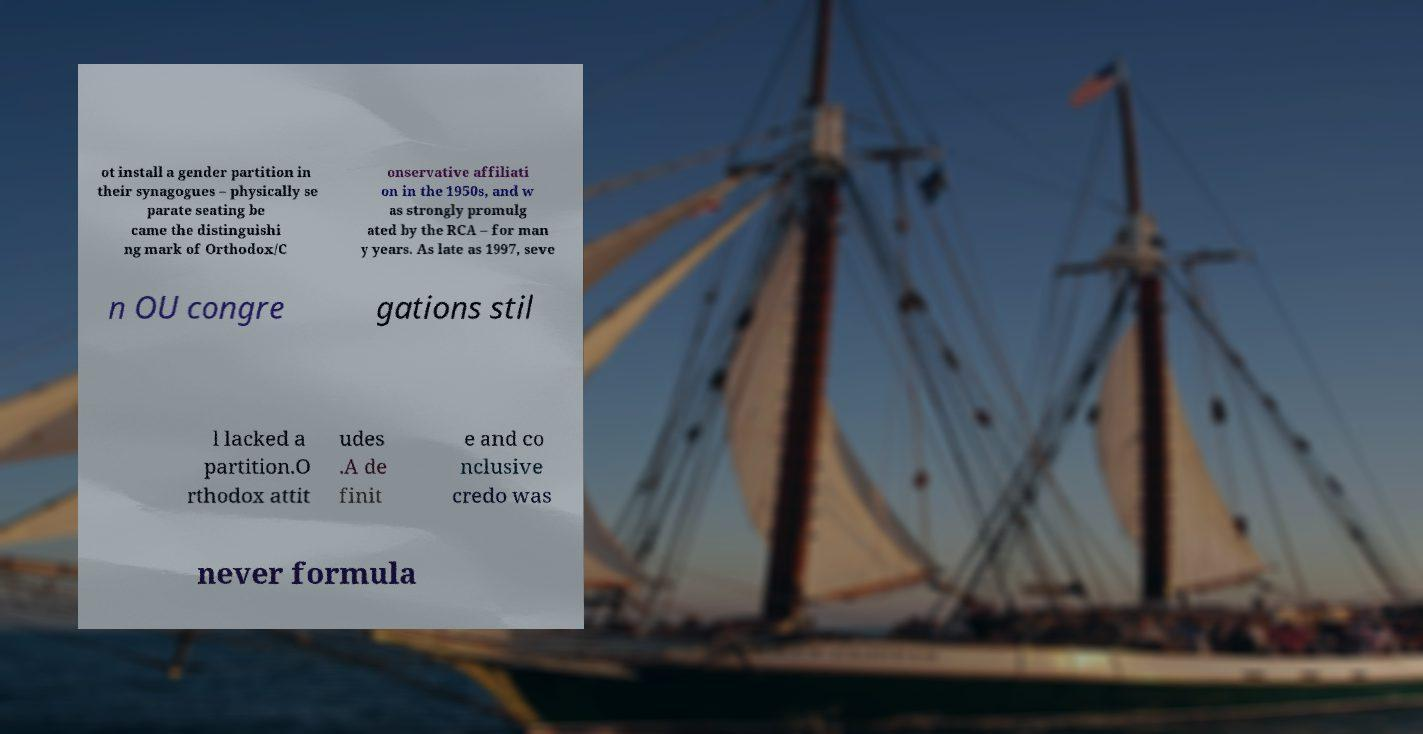Could you assist in decoding the text presented in this image and type it out clearly? ot install a gender partition in their synagogues – physically se parate seating be came the distinguishi ng mark of Orthodox/C onservative affiliati on in the 1950s, and w as strongly promulg ated by the RCA – for man y years. As late as 1997, seve n OU congre gations stil l lacked a partition.O rthodox attit udes .A de finit e and co nclusive credo was never formula 